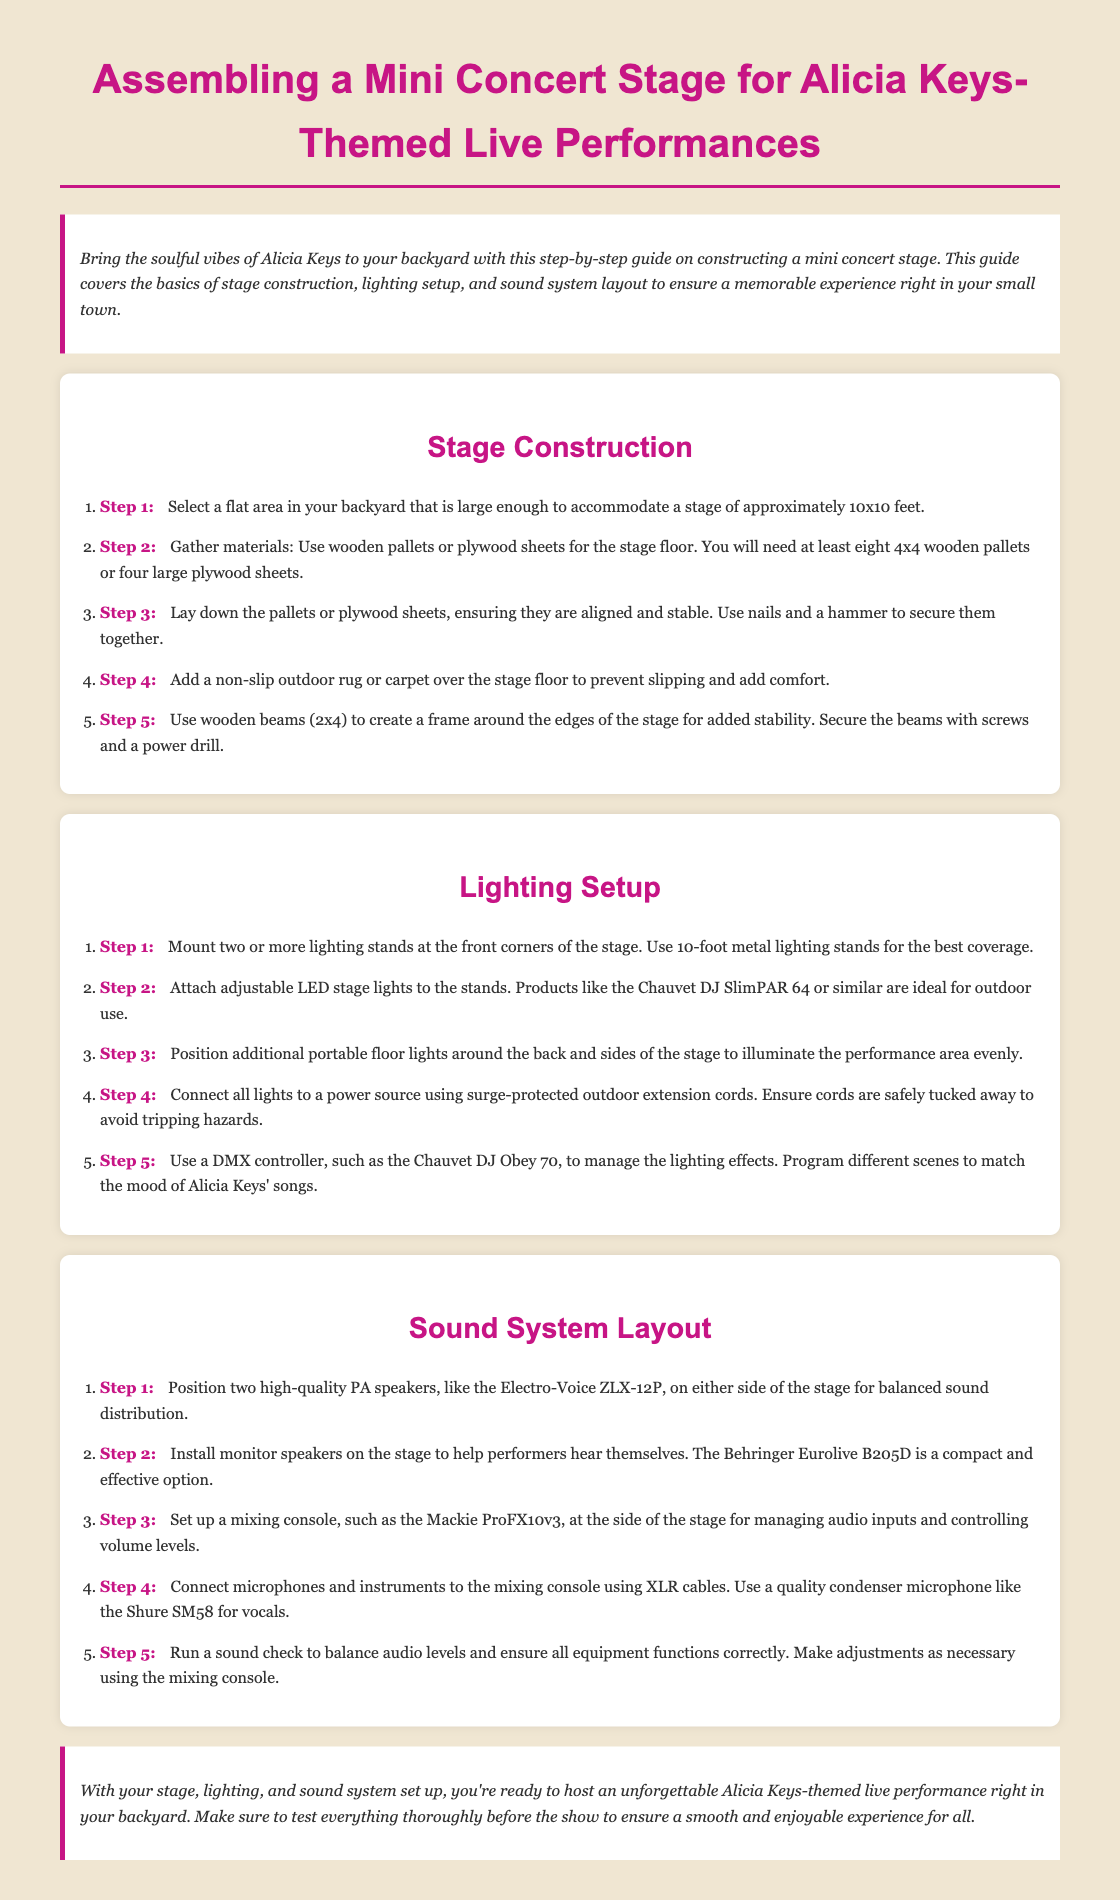What is the size of the stage needed? The document states the stage should be approximately 10x10 feet, indicating the required dimensions for the stage.
Answer: 10x10 feet How many wooden pallets are needed for the stage? It is specified that at least eight 4x4 wooden pallets or four large plywood sheets are necessary for constructing the stage floor.
Answer: Eight or four What type of lights are recommended for the stage? The document mentions using adjustable LED stage lights suitable for outdoor use, specifically suggesting the Chauvet DJ SlimPAR 64 or similar products.
Answer: Chauvet DJ SlimPAR 64 How many PA speakers should be positioned? The instructions indicate to position two high-quality PA speakers on either side of the stage for balanced sound distribution.
Answer: Two What should be used to create a frame around the edges of the stage? The guide advises using wooden beams (2x4) to create a frame around the edges of the stage for added stability.
Answer: Wooden beams What equipment is suggested for stage sound management? A mixing console, specifically the Mackie ProFX10v3, is recommended for managing audio inputs and controlling volume levels.
Answer: Mackie ProFX10v3 What must be done before hosting a performance? The document emphasizes the importance of performing a sound check to balance audio levels and ensure all equipment functions correctly.
Answer: Sound check Which lighting controller is recommended? The document suggests using a DMX controller, such as the Chauvet DJ Obey 70, for managing the lighting effects.
Answer: Chauvet DJ Obey 70 